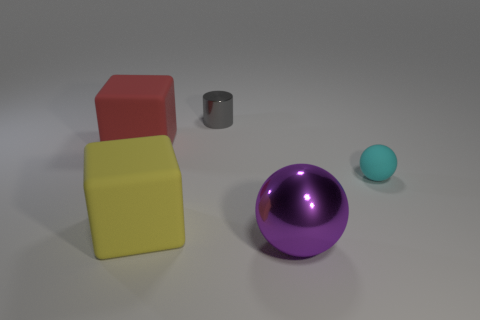Can you tell me about the lighting in this scene? Certainly. The scene is softly lit from above, creating gentle shadows beneath the objects. The diffuse light suggests an overcast sky or a singular broad light source above, which allows for the objects' colors and textures to be seen clearly without harsh, contrasting shadows. 